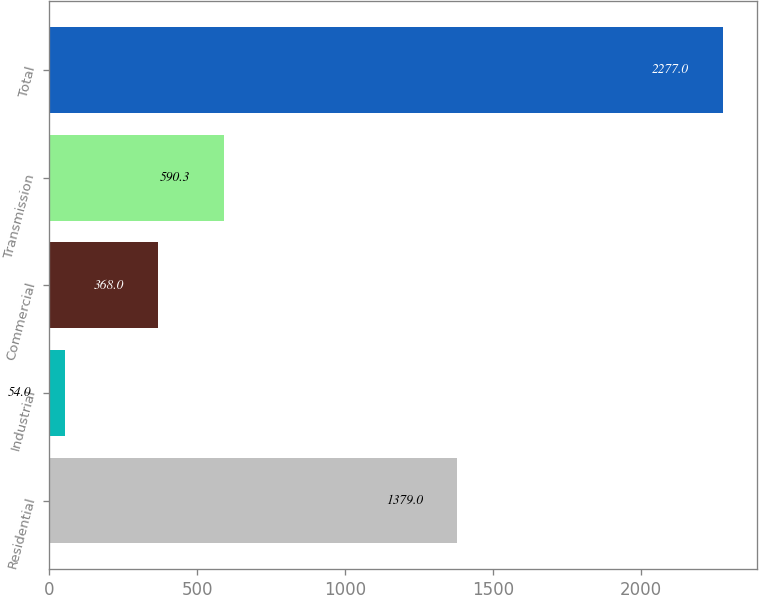Convert chart to OTSL. <chart><loc_0><loc_0><loc_500><loc_500><bar_chart><fcel>Residential<fcel>Industrial<fcel>Commercial<fcel>Transmission<fcel>Total<nl><fcel>1379<fcel>54<fcel>368<fcel>590.3<fcel>2277<nl></chart> 